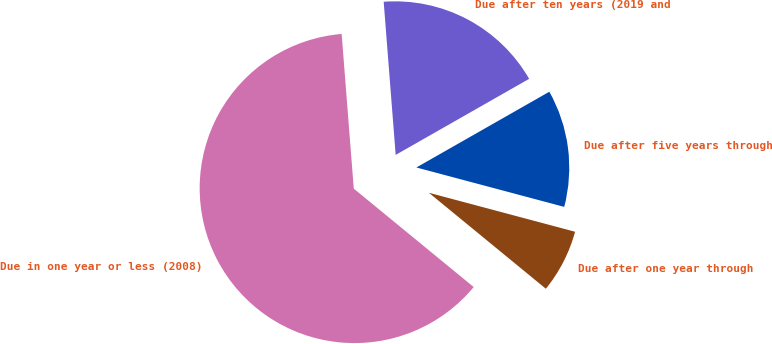Convert chart. <chart><loc_0><loc_0><loc_500><loc_500><pie_chart><fcel>Due in one year or less (2008)<fcel>Due after one year through<fcel>Due after five years through<fcel>Due after ten years (2019 and<nl><fcel>62.82%<fcel>6.79%<fcel>12.39%<fcel>18.0%<nl></chart> 